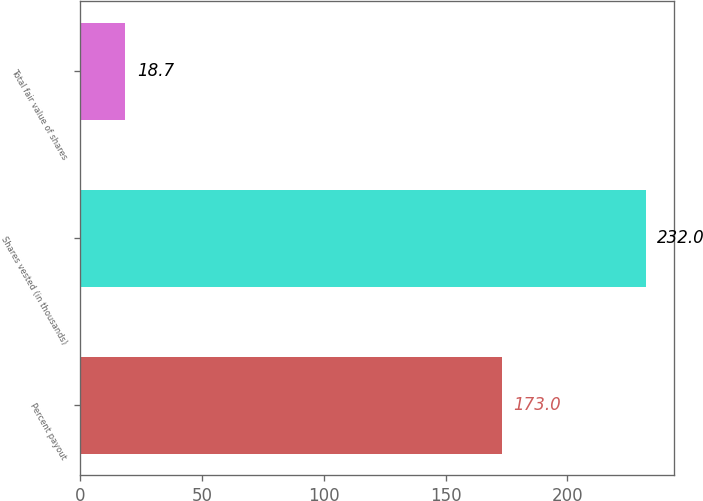<chart> <loc_0><loc_0><loc_500><loc_500><bar_chart><fcel>Percent payout<fcel>Shares vested (in thousands)<fcel>Total fair value of shares<nl><fcel>173<fcel>232<fcel>18.7<nl></chart> 